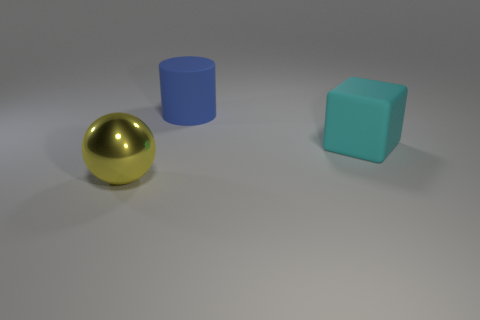Are there fewer big yellow objects that are behind the blue matte cylinder than cyan things?
Provide a short and direct response. Yes. Is the size of the thing that is to the left of the blue matte cylinder the same as the block?
Your response must be concise. Yes. What number of other blue objects are the same shape as the large blue thing?
Offer a very short reply. 0. There is another object that is made of the same material as the large blue thing; what size is it?
Your answer should be very brief. Large. Are there the same number of big blue rubber objects on the right side of the large blue rubber thing and large metallic objects?
Give a very brief answer. No. Is the color of the big rubber cube the same as the metal object?
Provide a short and direct response. No. There is a object right of the blue object; does it have the same shape as the large matte thing behind the large cyan matte cube?
Keep it short and to the point. No. There is a object that is right of the large yellow ball and in front of the blue rubber cylinder; what is its color?
Your answer should be compact. Cyan. Are there any large matte blocks that are right of the large object that is on the right side of the large matte object on the left side of the cyan object?
Your answer should be compact. No. What number of objects are matte cubes or large purple metallic cylinders?
Offer a very short reply. 1. 